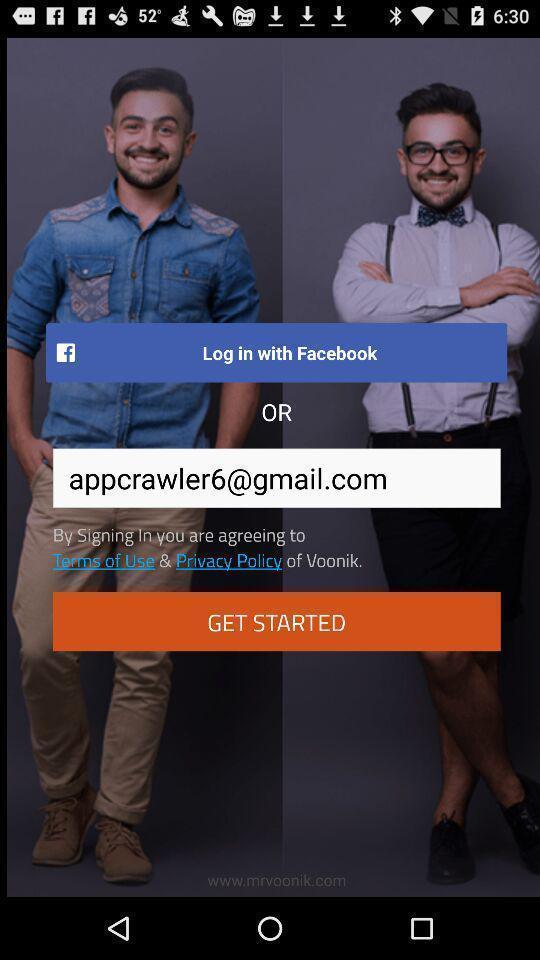What details can you identify in this image? Welcome and log-in page for an application. 